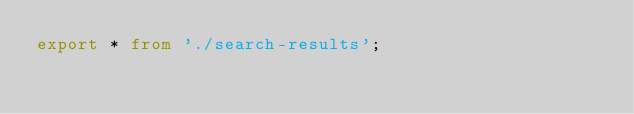Convert code to text. <code><loc_0><loc_0><loc_500><loc_500><_TypeScript_>export * from './search-results';
</code> 